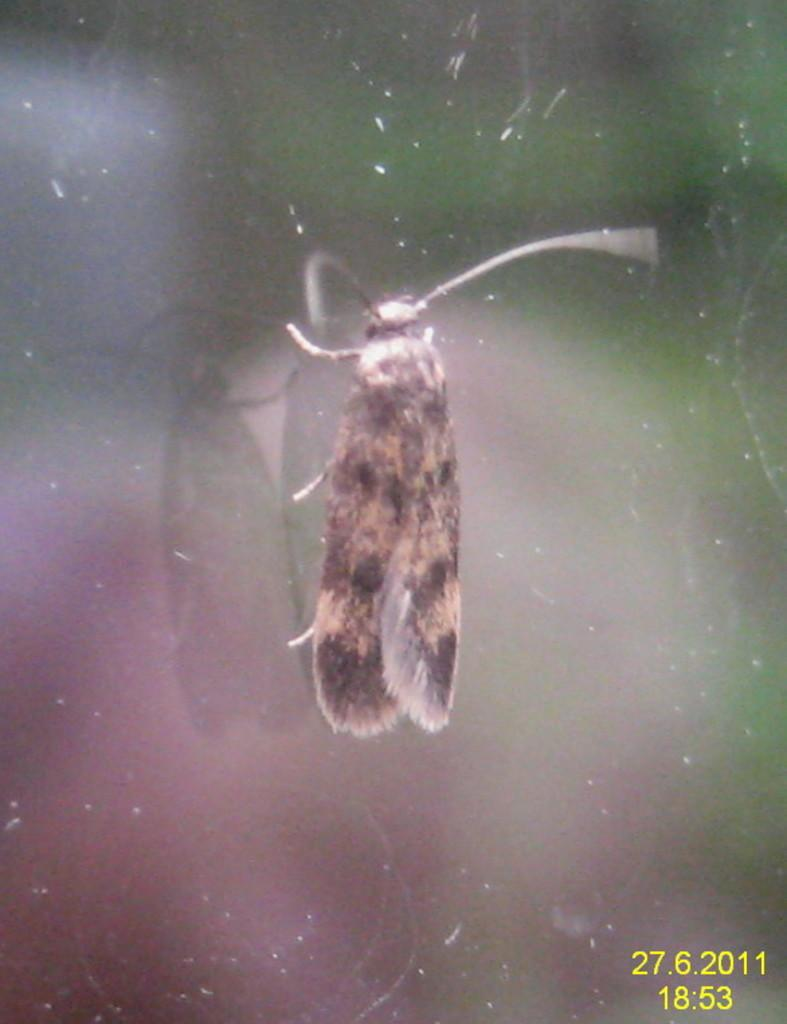What type of creature is present in the image? There is an insect in the image. Where is the insect located? The insect is on the glass. Are there any numbers visible in the image? Yes, there are numbers visible in the bottom right corner of the image. What is the color of the insect? The insect is brown in color. What type of sign can be seen in the image? There is no sign present in the image; it features an insect on the glass and numbers in the bottom right corner. How many ducks are visible in the image? There are no ducks present in the image. 